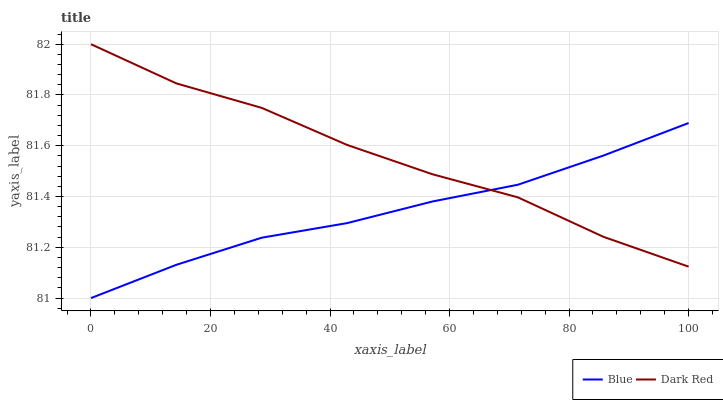Does Blue have the minimum area under the curve?
Answer yes or no. Yes. Does Dark Red have the maximum area under the curve?
Answer yes or no. Yes. Does Dark Red have the minimum area under the curve?
Answer yes or no. No. Is Blue the smoothest?
Answer yes or no. Yes. Is Dark Red the roughest?
Answer yes or no. Yes. Is Dark Red the smoothest?
Answer yes or no. No. Does Blue have the lowest value?
Answer yes or no. Yes. Does Dark Red have the lowest value?
Answer yes or no. No. Does Dark Red have the highest value?
Answer yes or no. Yes. Does Dark Red intersect Blue?
Answer yes or no. Yes. Is Dark Red less than Blue?
Answer yes or no. No. Is Dark Red greater than Blue?
Answer yes or no. No. 